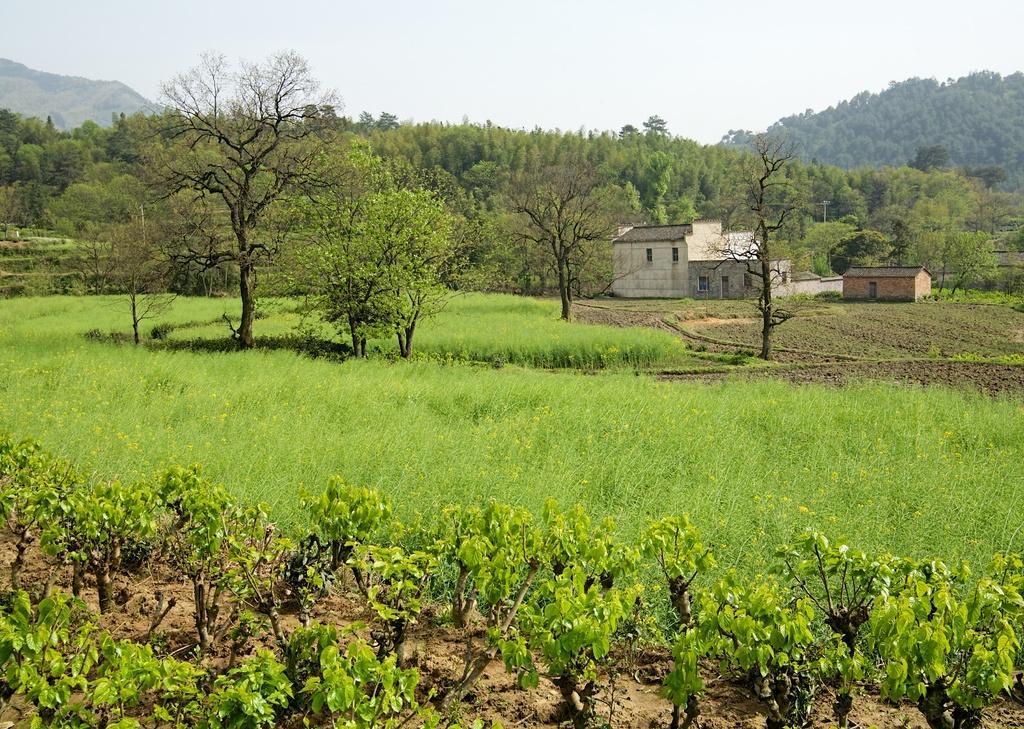Could you give a brief overview of what you see in this image? In this image there are plants, grass and trees, in the background of the image there are houses, electric poles with cables and mountains. 